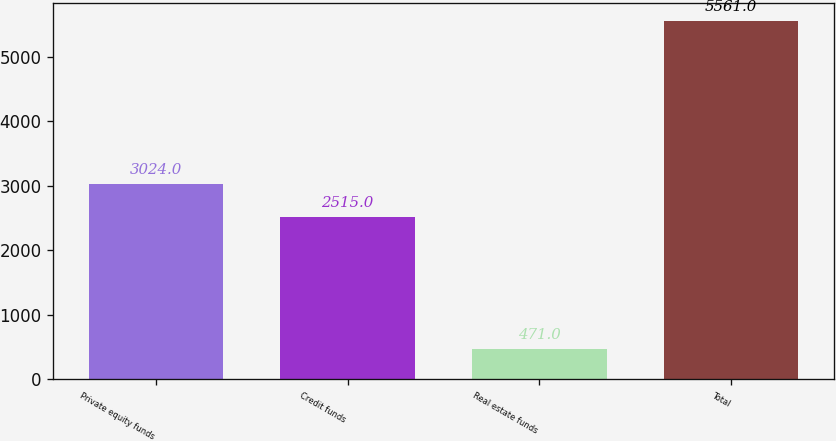<chart> <loc_0><loc_0><loc_500><loc_500><bar_chart><fcel>Private equity funds<fcel>Credit funds<fcel>Real estate funds<fcel>Total<nl><fcel>3024<fcel>2515<fcel>471<fcel>5561<nl></chart> 